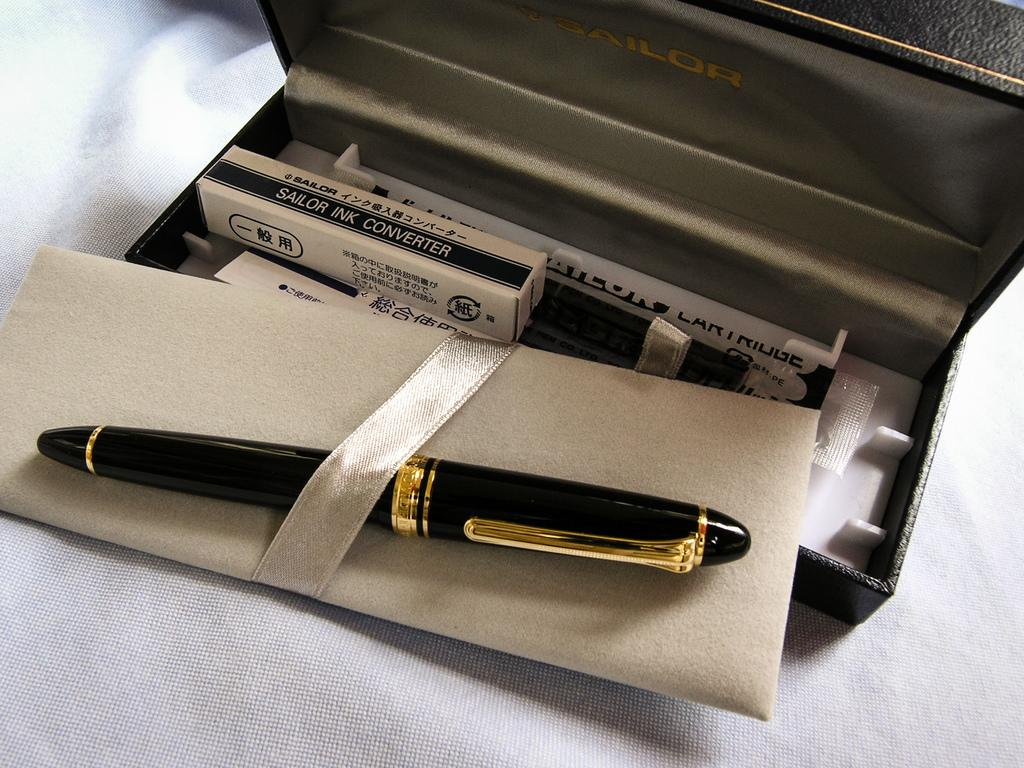What is the main object on the platform in the image? There is a box on a platform in the image. What stationary item can be seen in the image? There is a pen in the image. Can you describe any other objects in the image? There are some unspecified objects in the image. What type of blood is visible on the pen in the image? There is no blood visible on the pen in the image. What advice can be seen written on the box in the image? There is no advice written on the box in the image. 